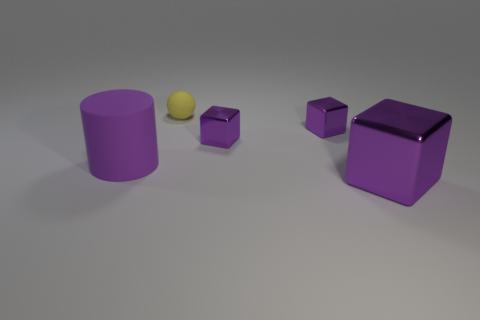Does the tiny sphere have the same material as the large object that is to the left of the big metal thing?
Ensure brevity in your answer.  Yes. What is the large purple cylinder made of?
Provide a succinct answer. Rubber. There is a purple thing that is made of the same material as the small yellow thing; what is its shape?
Keep it short and to the point. Cylinder. What number of other things are there of the same shape as the yellow object?
Your answer should be very brief. 0. What number of metal things are in front of the tiny sphere?
Your response must be concise. 3. There is a shiny block that is in front of the large rubber cylinder; does it have the same size as the thing on the left side of the tiny yellow object?
Ensure brevity in your answer.  Yes. How many other objects are there of the same size as the cylinder?
Your answer should be compact. 1. The object that is in front of the large purple object that is to the left of the big thing to the right of the big purple matte cylinder is made of what material?
Make the answer very short. Metal. Do the cylinder and the purple cube that is in front of the purple rubber cylinder have the same size?
Keep it short and to the point. Yes. Is there a metal thing that has the same color as the big rubber thing?
Provide a short and direct response. Yes. 